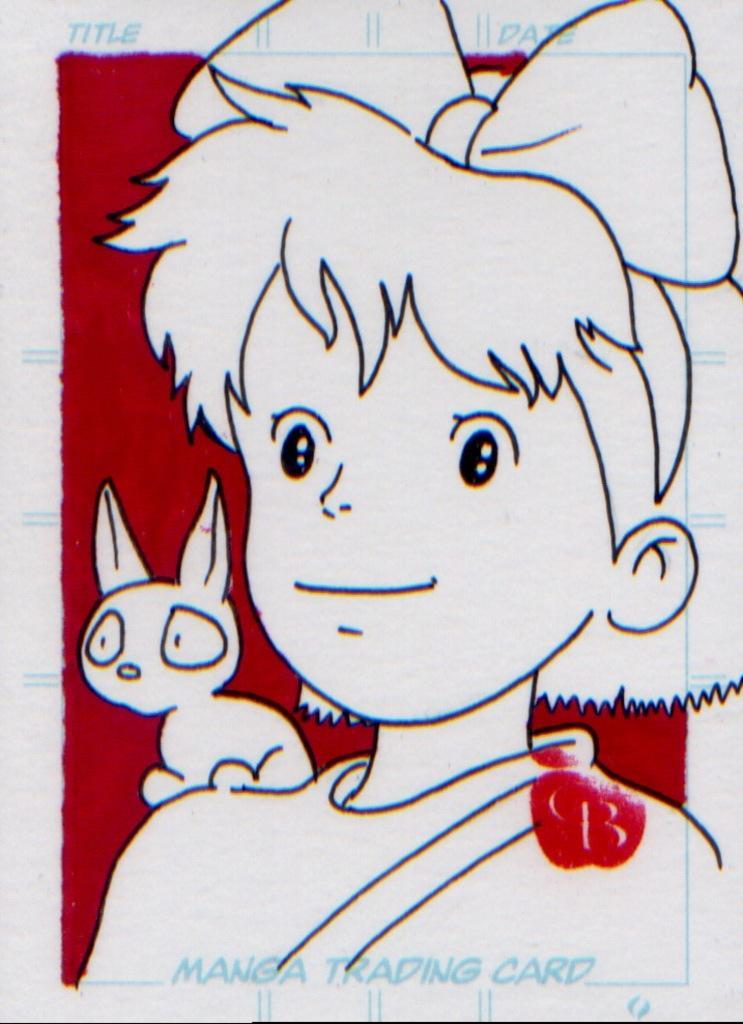Could you give a brief overview of what you see in this image? Here in this picture we can see a sketch present on the paper over there and some part is covered with red color over there. 